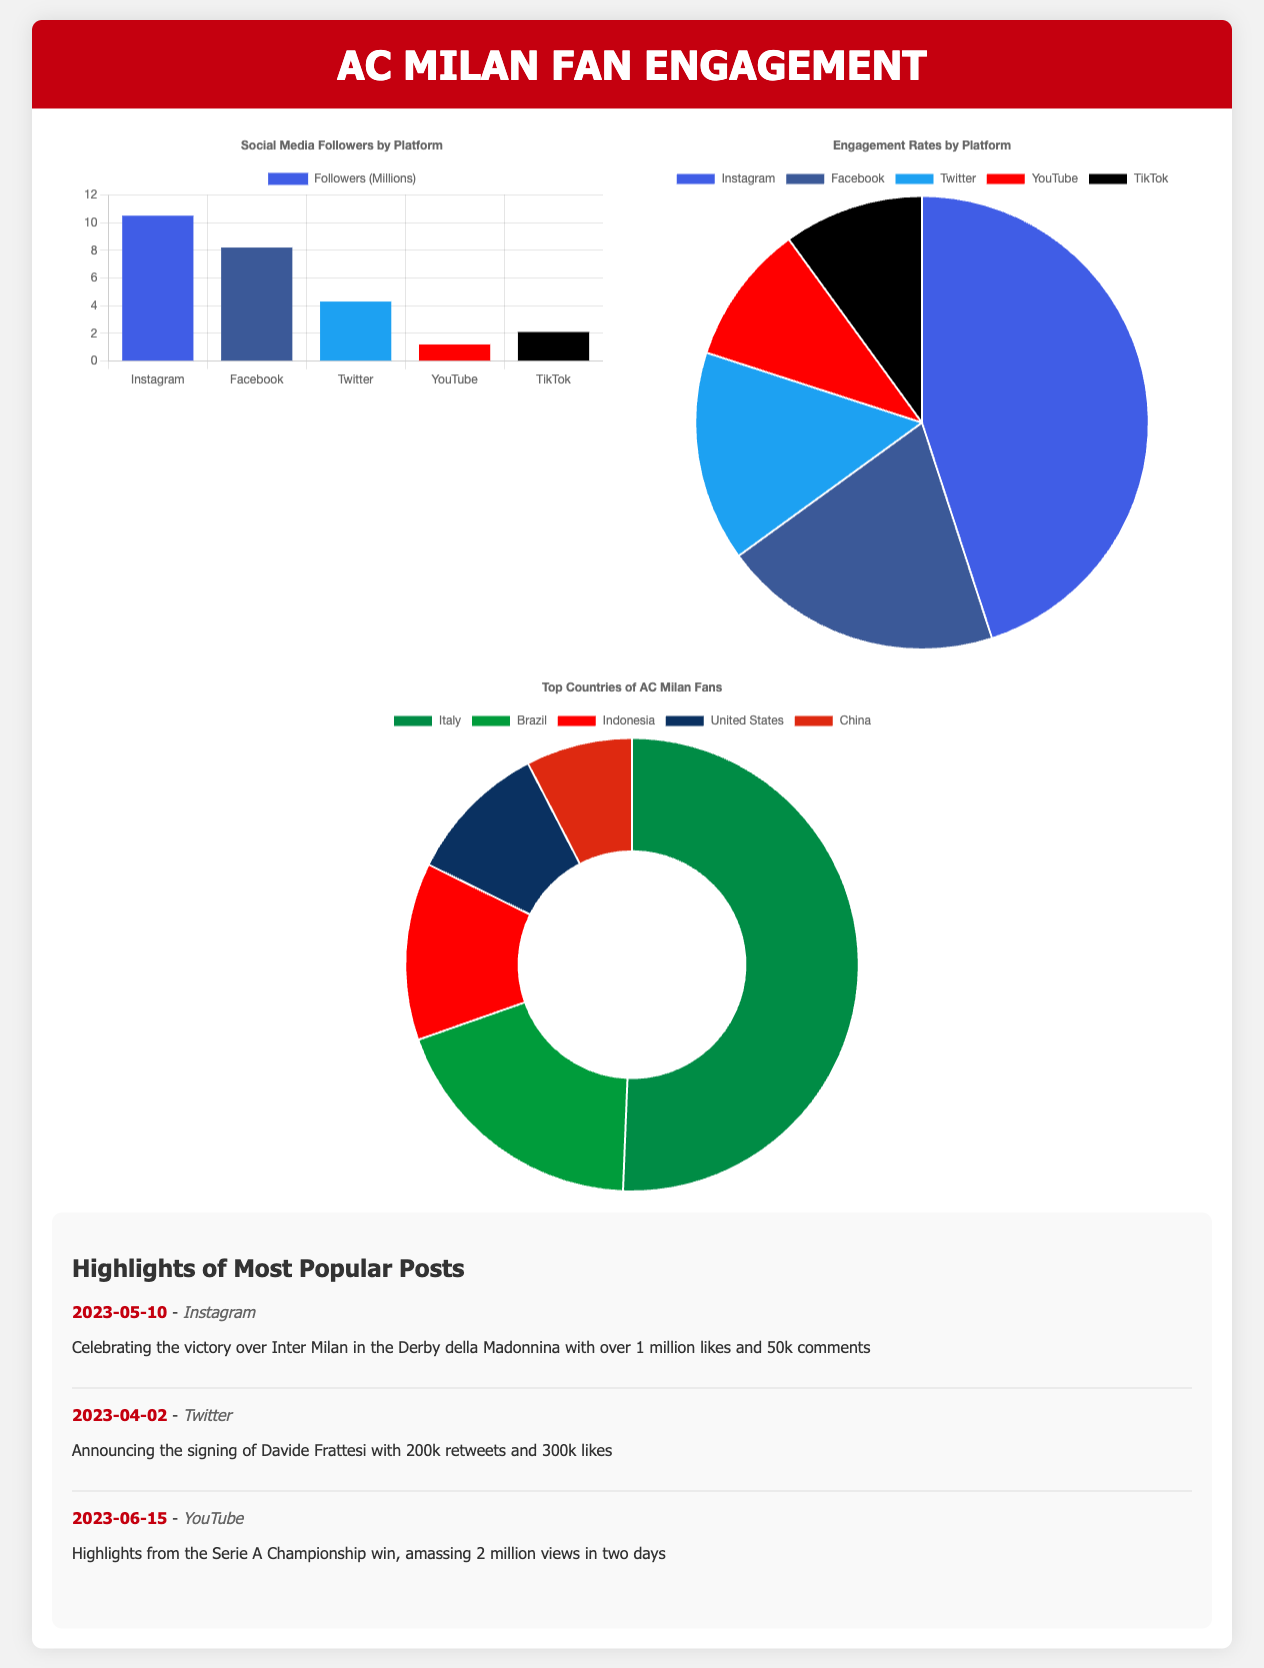what is the total number of Instagram followers? The total Instagram followers are given as 10.5 million in the social media chart.
Answer: 10.5 million which platform has the highest engagement rate? The engagement rates are shown in the pie chart, and Instagram has the highest rate at 45%.
Answer: Instagram how many likes did the Instagram post on 2023-05-10 receive? The highlight for the Instagram post on this date states it received over 1 million likes.
Answer: 1 million what is the engagement rate for YouTube? The engagement rates indicate that YouTube has a rate of 10%.
Answer: 10% which country has the largest fanbase for AC Milan? The top countries chart shows that Italy has the largest percentage with 40%.
Answer: Italy how many retweets did the Twitter announcement receive on 2023-04-02? The highlight mentions 200k retweets for the announcement made on this date.
Answer: 200k how many platforms are listed in the social media followers chart? The chart presents followers from five different platforms.
Answer: 5 which platform had the most popular video with 2 million views? The highlight states that the YouTube post had the most views in two days, with 2 million views.
Answer: YouTube what is the percentage of AC Milan fans from Brazil? The top countries chart indicates that Brazil accounts for 15% of the fanbase.
Answer: 15% 